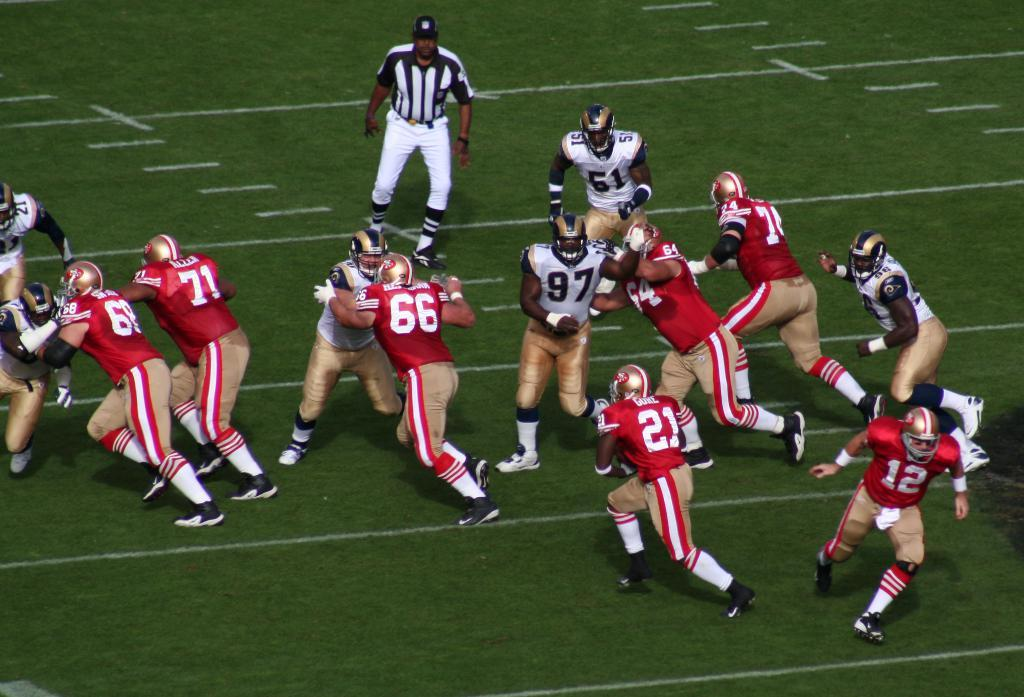What are the men in the image doing? The men in the image are playing a game on the ground. Can you describe the role of the man standing in the back? The man standing in the back appears to be an umpire. What is the opinion of the downtown area in the image? There is no mention of a downtown area in the image, so it is not possible to determine its opinion. 